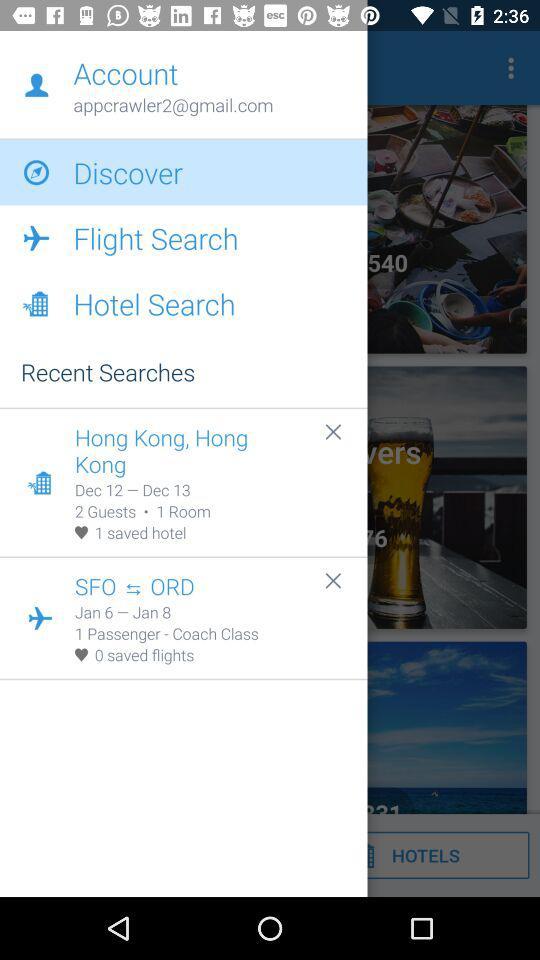How many hotels have been saved? There is 1 saved hotel. 